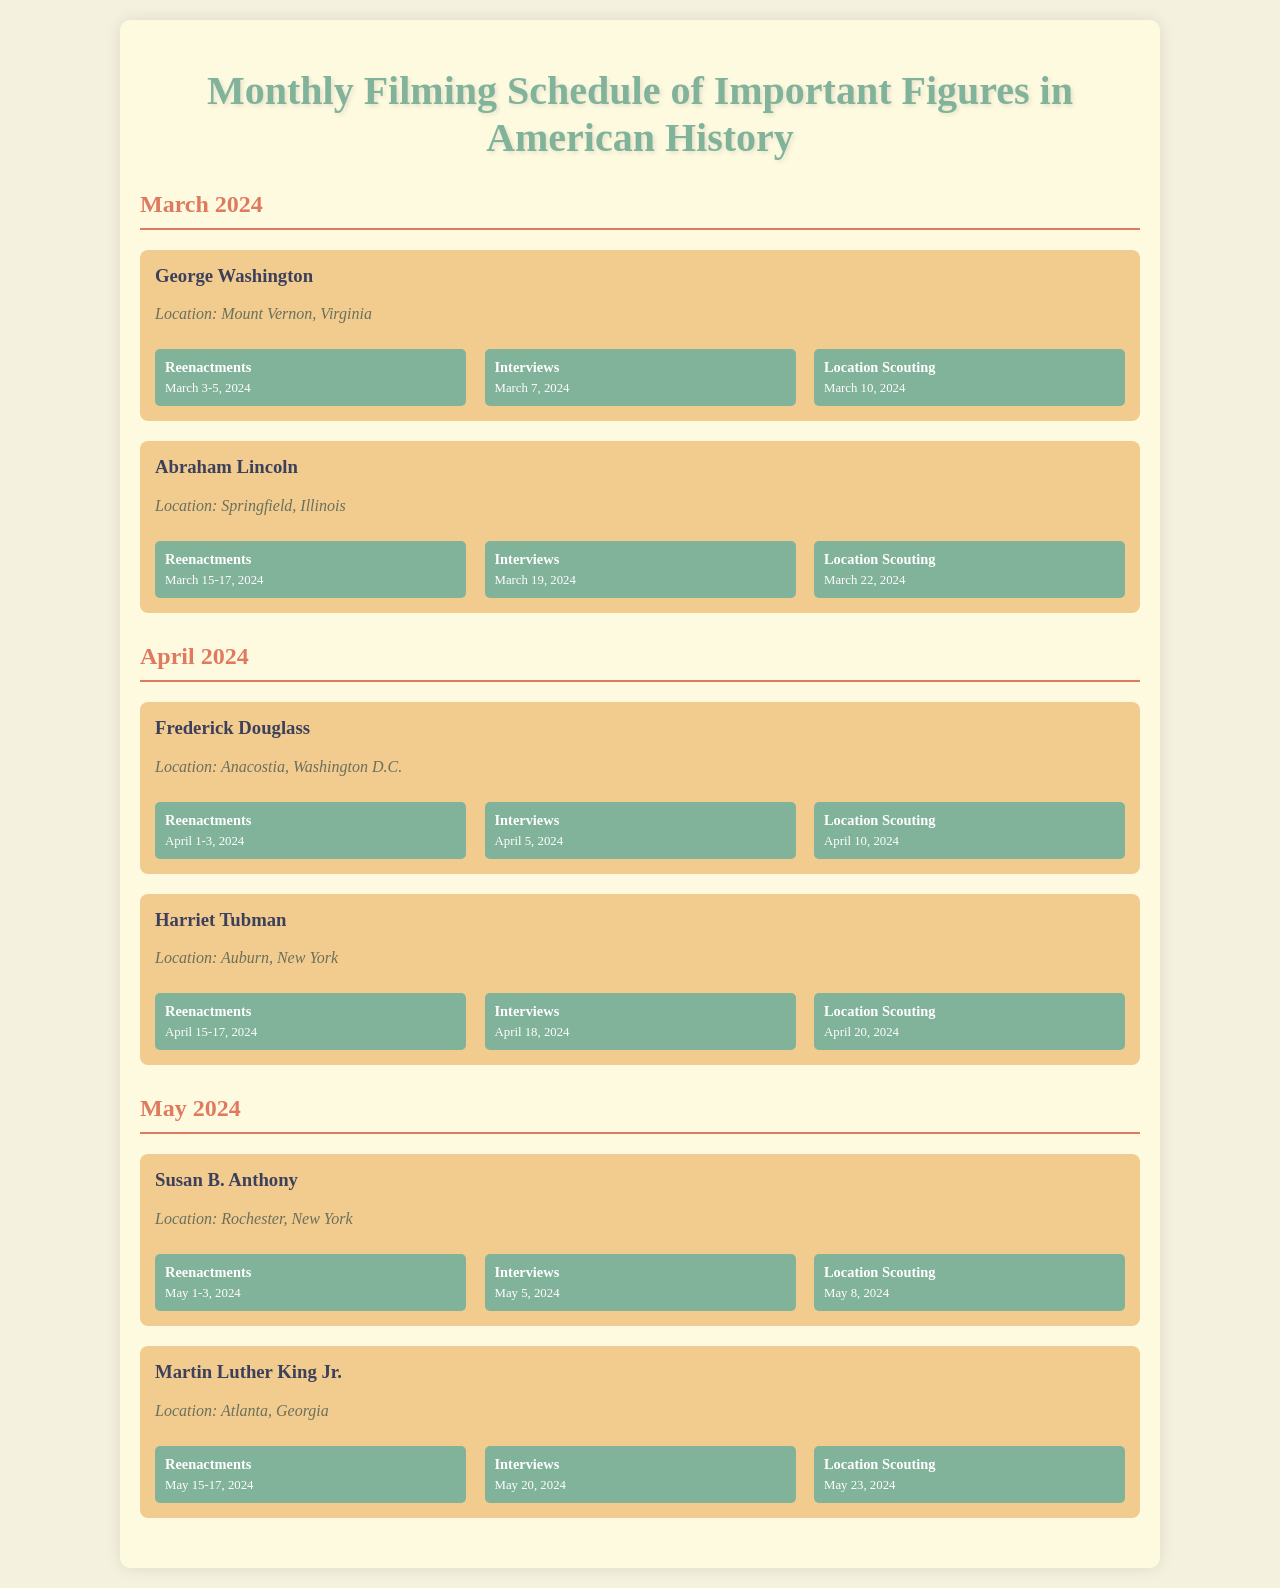What are the shoot dates for George Washington's reenactments? The shoot dates for George Washington's reenactments are March 3-5, 2024.
Answer: March 3-5, 2024 Where is the filming for Abraham Lincoln taking place? The filming for Abraham Lincoln is taking place in Springfield, Illinois.
Answer: Springfield, Illinois What is the date for Susan B. Anthony's interviews? The date for Susan B. Anthony's interviews is May 5, 2024.
Answer: May 5, 2024 Who is scheduled for reenactments in April 2024? Frederick Douglass and Harriet Tubman are scheduled for reenactments in April 2024.
Answer: Frederick Douglass and Harriet Tubman When is the location scouting for Martin Luther King Jr.? The location scouting for Martin Luther King Jr. is on May 23, 2024.
Answer: May 23, 2024 How many days are scheduled for George Washington's reenactments? George Washington's reenactments are scheduled for three days, from March 3 to March 5, 2024.
Answer: Three days Which figure has interviews scheduled on March 19, 2024? The figure with interviews scheduled on March 19, 2024, is Abraham Lincoln.
Answer: Abraham Lincoln What month features filming for Frederick Douglass? Filming for Frederick Douglass features in April 2024.
Answer: April 2024 What type of event is scheduled for March 22, 2024? The event scheduled for March 22, 2024, is location scouting.
Answer: Location scouting 